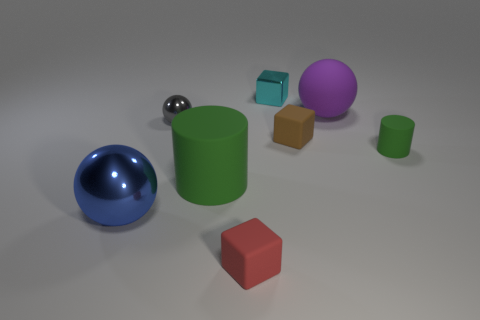How many brown rubber things are the same shape as the big purple rubber object?
Offer a very short reply. 0. There is a gray object that is the same material as the big blue thing; what shape is it?
Your answer should be very brief. Sphere. The green rubber thing that is on the left side of the large sphere that is on the right side of the small matte block behind the small matte cylinder is what shape?
Provide a succinct answer. Cylinder. Are there more small gray objects than large red rubber objects?
Ensure brevity in your answer.  Yes. What is the material of the red thing that is the same shape as the small brown matte object?
Your response must be concise. Rubber. Is the large blue thing made of the same material as the small cyan block?
Offer a very short reply. Yes. Is the number of gray objects behind the cyan metallic thing greater than the number of gray objects?
Ensure brevity in your answer.  No. What material is the ball that is to the right of the tiny cube that is in front of the rubber cylinder that is to the right of the large green cylinder?
Give a very brief answer. Rubber. How many objects are either big gray matte cylinders or rubber objects that are on the right side of the purple rubber sphere?
Ensure brevity in your answer.  1. Do the cylinder that is in front of the small rubber cylinder and the rubber sphere have the same color?
Your answer should be compact. No. 